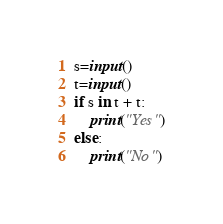<code> <loc_0><loc_0><loc_500><loc_500><_Python_>s=input()
t=input()
if s in t + t:
    print("Yes")
else:
    print("No")</code> 